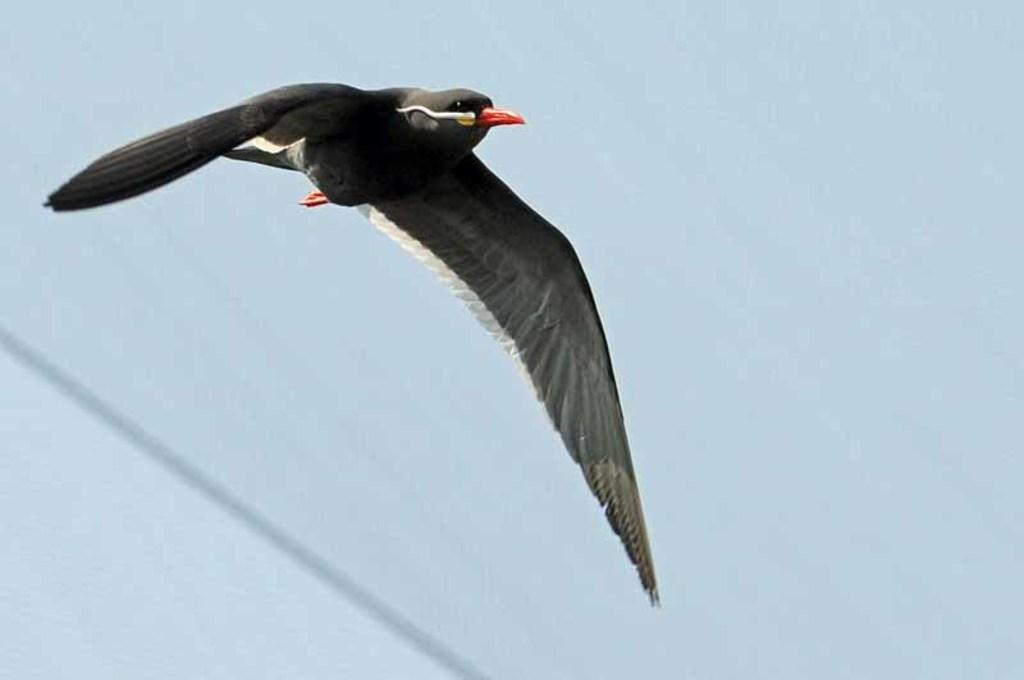What type of animal is in the image? There is a bird in the image. What colors can be seen on the bird? The bird has white, black, and red colors. Where is the bird located in the image? To produce the conversation, we first identify the main subject of the image, which is the bird. We then describe the bird's colors and location, which are known from the provided facts. We avoid yes/no questions and ensure that the language is simple and clear. Absurd Question/Answer: What type of vase is being used to serve the meal in the image? There is no vase or meal present in the image; it features a bird in the air. How deep is the hole that the bird is flying into in the image? There is no hole in the image; the bird is flying in the sky. What type of vase is being used to serve the meal in the image? There is no vase or meal present in the image; it features a bird in the air. How deep is the hole that the bird is flying into in the image? There is no hole in the image; the bird is flying in the sky. 